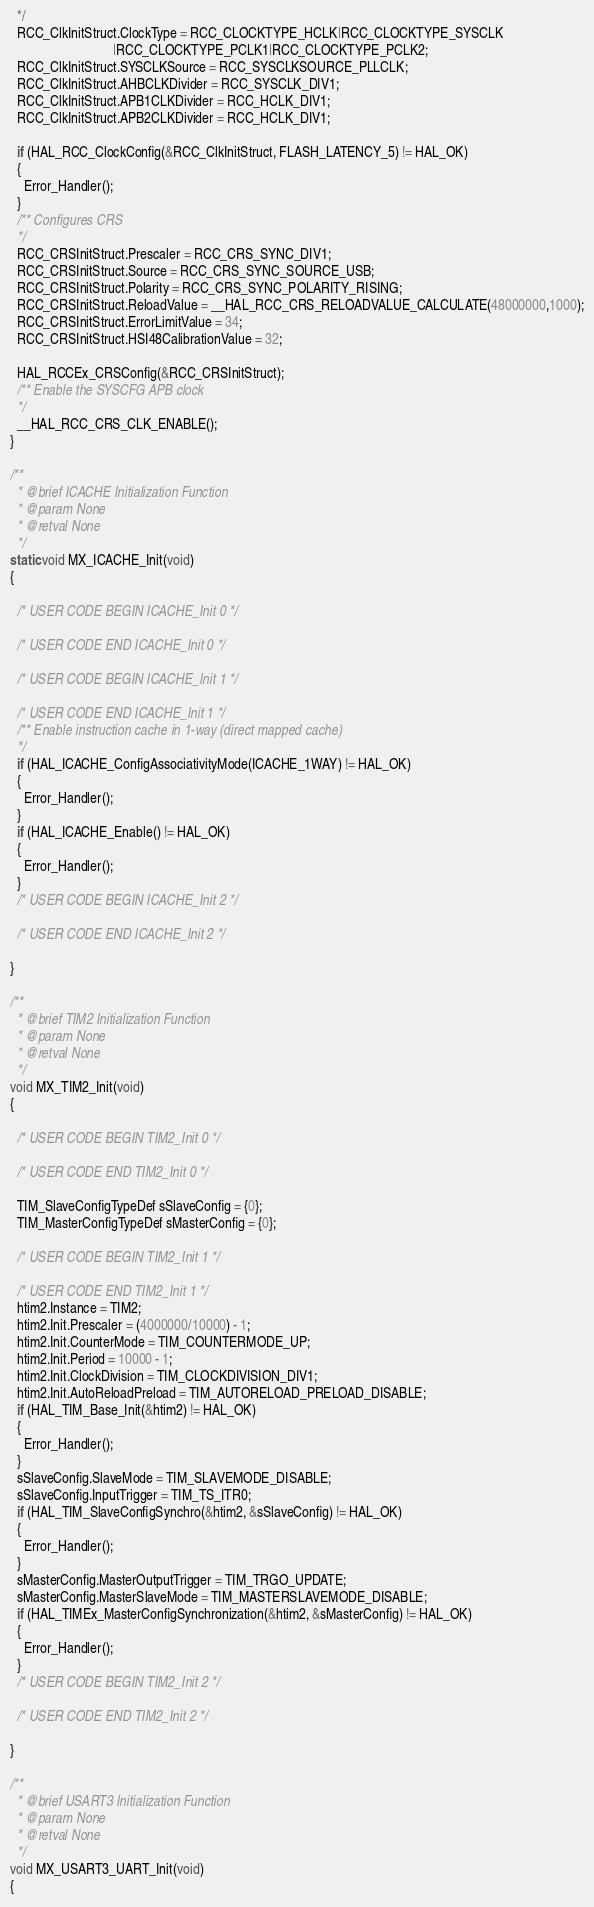<code> <loc_0><loc_0><loc_500><loc_500><_C_>  */
  RCC_ClkInitStruct.ClockType = RCC_CLOCKTYPE_HCLK|RCC_CLOCKTYPE_SYSCLK
                              |RCC_CLOCKTYPE_PCLK1|RCC_CLOCKTYPE_PCLK2;
  RCC_ClkInitStruct.SYSCLKSource = RCC_SYSCLKSOURCE_PLLCLK;
  RCC_ClkInitStruct.AHBCLKDivider = RCC_SYSCLK_DIV1;
  RCC_ClkInitStruct.APB1CLKDivider = RCC_HCLK_DIV1;
  RCC_ClkInitStruct.APB2CLKDivider = RCC_HCLK_DIV1;

  if (HAL_RCC_ClockConfig(&RCC_ClkInitStruct, FLASH_LATENCY_5) != HAL_OK)
  {
    Error_Handler();
  }
  /** Configures CRS
  */
  RCC_CRSInitStruct.Prescaler = RCC_CRS_SYNC_DIV1;
  RCC_CRSInitStruct.Source = RCC_CRS_SYNC_SOURCE_USB;
  RCC_CRSInitStruct.Polarity = RCC_CRS_SYNC_POLARITY_RISING;
  RCC_CRSInitStruct.ReloadValue = __HAL_RCC_CRS_RELOADVALUE_CALCULATE(48000000,1000);
  RCC_CRSInitStruct.ErrorLimitValue = 34;
  RCC_CRSInitStruct.HSI48CalibrationValue = 32;

  HAL_RCCEx_CRSConfig(&RCC_CRSInitStruct);
  /** Enable the SYSCFG APB clock
  */
  __HAL_RCC_CRS_CLK_ENABLE();
}

/**
  * @brief ICACHE Initialization Function
  * @param None
  * @retval None
  */
static void MX_ICACHE_Init(void)
{

  /* USER CODE BEGIN ICACHE_Init 0 */

  /* USER CODE END ICACHE_Init 0 */

  /* USER CODE BEGIN ICACHE_Init 1 */

  /* USER CODE END ICACHE_Init 1 */
  /** Enable instruction cache in 1-way (direct mapped cache)
  */
  if (HAL_ICACHE_ConfigAssociativityMode(ICACHE_1WAY) != HAL_OK)
  {
    Error_Handler();
  }
  if (HAL_ICACHE_Enable() != HAL_OK)
  {
    Error_Handler();
  }
  /* USER CODE BEGIN ICACHE_Init 2 */

  /* USER CODE END ICACHE_Init 2 */

}

/**
  * @brief TIM2 Initialization Function
  * @param None
  * @retval None
  */
void MX_TIM2_Init(void)
{

  /* USER CODE BEGIN TIM2_Init 0 */

  /* USER CODE END TIM2_Init 0 */

  TIM_SlaveConfigTypeDef sSlaveConfig = {0};
  TIM_MasterConfigTypeDef sMasterConfig = {0};

  /* USER CODE BEGIN TIM2_Init 1 */

  /* USER CODE END TIM2_Init 1 */
  htim2.Instance = TIM2;
  htim2.Init.Prescaler = (4000000/10000) - 1;
  htim2.Init.CounterMode = TIM_COUNTERMODE_UP;
  htim2.Init.Period = 10000 - 1;
  htim2.Init.ClockDivision = TIM_CLOCKDIVISION_DIV1;
  htim2.Init.AutoReloadPreload = TIM_AUTORELOAD_PRELOAD_DISABLE;
  if (HAL_TIM_Base_Init(&htim2) != HAL_OK)
  {
    Error_Handler();
  }
  sSlaveConfig.SlaveMode = TIM_SLAVEMODE_DISABLE;
  sSlaveConfig.InputTrigger = TIM_TS_ITR0;
  if (HAL_TIM_SlaveConfigSynchro(&htim2, &sSlaveConfig) != HAL_OK)
  {
    Error_Handler();
  }
  sMasterConfig.MasterOutputTrigger = TIM_TRGO_UPDATE;
  sMasterConfig.MasterSlaveMode = TIM_MASTERSLAVEMODE_DISABLE;
  if (HAL_TIMEx_MasterConfigSynchronization(&htim2, &sMasterConfig) != HAL_OK)
  {
    Error_Handler();
  }
  /* USER CODE BEGIN TIM2_Init 2 */

  /* USER CODE END TIM2_Init 2 */

}

/**
  * @brief USART3 Initialization Function
  * @param None
  * @retval None
  */
void MX_USART3_UART_Init(void)
{
</code> 